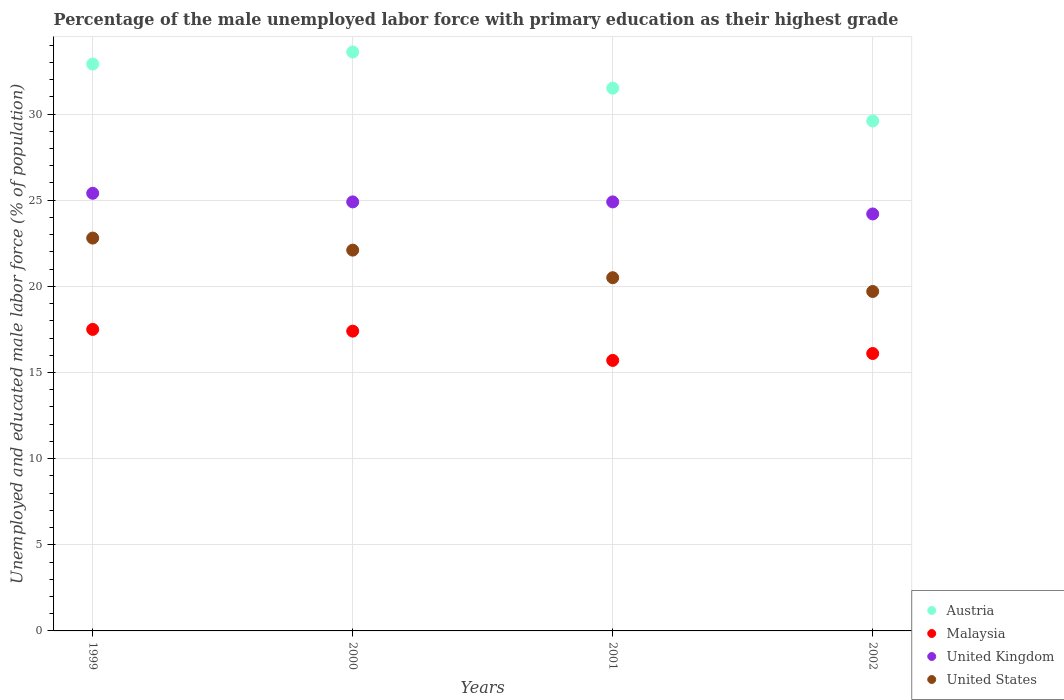How many different coloured dotlines are there?
Keep it short and to the point. 4. What is the percentage of the unemployed male labor force with primary education in United Kingdom in 2001?
Keep it short and to the point. 24.9. Across all years, what is the maximum percentage of the unemployed male labor force with primary education in Austria?
Your answer should be very brief. 33.6. Across all years, what is the minimum percentage of the unemployed male labor force with primary education in United Kingdom?
Keep it short and to the point. 24.2. What is the total percentage of the unemployed male labor force with primary education in Austria in the graph?
Your response must be concise. 127.6. What is the difference between the percentage of the unemployed male labor force with primary education in United States in 2000 and that in 2001?
Your answer should be very brief. 1.6. What is the difference between the percentage of the unemployed male labor force with primary education in United Kingdom in 2001 and the percentage of the unemployed male labor force with primary education in Austria in 2000?
Offer a terse response. -8.7. What is the average percentage of the unemployed male labor force with primary education in United Kingdom per year?
Provide a succinct answer. 24.85. In the year 1999, what is the difference between the percentage of the unemployed male labor force with primary education in United States and percentage of the unemployed male labor force with primary education in United Kingdom?
Keep it short and to the point. -2.6. In how many years, is the percentage of the unemployed male labor force with primary education in Austria greater than 4 %?
Offer a very short reply. 4. What is the ratio of the percentage of the unemployed male labor force with primary education in United States in 2001 to that in 2002?
Offer a very short reply. 1.04. Is the percentage of the unemployed male labor force with primary education in United States in 1999 less than that in 2001?
Keep it short and to the point. No. Is the difference between the percentage of the unemployed male labor force with primary education in United States in 1999 and 2001 greater than the difference between the percentage of the unemployed male labor force with primary education in United Kingdom in 1999 and 2001?
Provide a succinct answer. Yes. What is the difference between the highest and the second highest percentage of the unemployed male labor force with primary education in Malaysia?
Your answer should be compact. 0.1. What is the difference between the highest and the lowest percentage of the unemployed male labor force with primary education in Austria?
Your answer should be very brief. 4. In how many years, is the percentage of the unemployed male labor force with primary education in Malaysia greater than the average percentage of the unemployed male labor force with primary education in Malaysia taken over all years?
Your answer should be very brief. 2. Is the sum of the percentage of the unemployed male labor force with primary education in Austria in 2000 and 2002 greater than the maximum percentage of the unemployed male labor force with primary education in United States across all years?
Your answer should be compact. Yes. Is it the case that in every year, the sum of the percentage of the unemployed male labor force with primary education in United Kingdom and percentage of the unemployed male labor force with primary education in Austria  is greater than the sum of percentage of the unemployed male labor force with primary education in Malaysia and percentage of the unemployed male labor force with primary education in United States?
Keep it short and to the point. Yes. Does the percentage of the unemployed male labor force with primary education in Austria monotonically increase over the years?
Keep it short and to the point. No. Is the percentage of the unemployed male labor force with primary education in United Kingdom strictly less than the percentage of the unemployed male labor force with primary education in United States over the years?
Provide a short and direct response. No. How many dotlines are there?
Your response must be concise. 4. How many years are there in the graph?
Your answer should be very brief. 4. Does the graph contain grids?
Give a very brief answer. Yes. Where does the legend appear in the graph?
Keep it short and to the point. Bottom right. What is the title of the graph?
Give a very brief answer. Percentage of the male unemployed labor force with primary education as their highest grade. What is the label or title of the X-axis?
Offer a terse response. Years. What is the label or title of the Y-axis?
Give a very brief answer. Unemployed and educated male labor force (% of population). What is the Unemployed and educated male labor force (% of population) in Austria in 1999?
Your answer should be compact. 32.9. What is the Unemployed and educated male labor force (% of population) of United Kingdom in 1999?
Make the answer very short. 25.4. What is the Unemployed and educated male labor force (% of population) in United States in 1999?
Make the answer very short. 22.8. What is the Unemployed and educated male labor force (% of population) of Austria in 2000?
Give a very brief answer. 33.6. What is the Unemployed and educated male labor force (% of population) in Malaysia in 2000?
Provide a short and direct response. 17.4. What is the Unemployed and educated male labor force (% of population) of United Kingdom in 2000?
Your response must be concise. 24.9. What is the Unemployed and educated male labor force (% of population) of United States in 2000?
Make the answer very short. 22.1. What is the Unemployed and educated male labor force (% of population) in Austria in 2001?
Make the answer very short. 31.5. What is the Unemployed and educated male labor force (% of population) in Malaysia in 2001?
Provide a short and direct response. 15.7. What is the Unemployed and educated male labor force (% of population) in United Kingdom in 2001?
Ensure brevity in your answer.  24.9. What is the Unemployed and educated male labor force (% of population) of Austria in 2002?
Your answer should be compact. 29.6. What is the Unemployed and educated male labor force (% of population) in Malaysia in 2002?
Make the answer very short. 16.1. What is the Unemployed and educated male labor force (% of population) of United Kingdom in 2002?
Provide a succinct answer. 24.2. What is the Unemployed and educated male labor force (% of population) of United States in 2002?
Make the answer very short. 19.7. Across all years, what is the maximum Unemployed and educated male labor force (% of population) of Austria?
Ensure brevity in your answer.  33.6. Across all years, what is the maximum Unemployed and educated male labor force (% of population) of United Kingdom?
Provide a succinct answer. 25.4. Across all years, what is the maximum Unemployed and educated male labor force (% of population) of United States?
Provide a short and direct response. 22.8. Across all years, what is the minimum Unemployed and educated male labor force (% of population) of Austria?
Make the answer very short. 29.6. Across all years, what is the minimum Unemployed and educated male labor force (% of population) in Malaysia?
Offer a very short reply. 15.7. Across all years, what is the minimum Unemployed and educated male labor force (% of population) in United Kingdom?
Offer a terse response. 24.2. Across all years, what is the minimum Unemployed and educated male labor force (% of population) of United States?
Provide a succinct answer. 19.7. What is the total Unemployed and educated male labor force (% of population) of Austria in the graph?
Ensure brevity in your answer.  127.6. What is the total Unemployed and educated male labor force (% of population) of Malaysia in the graph?
Provide a succinct answer. 66.7. What is the total Unemployed and educated male labor force (% of population) in United Kingdom in the graph?
Provide a succinct answer. 99.4. What is the total Unemployed and educated male labor force (% of population) of United States in the graph?
Ensure brevity in your answer.  85.1. What is the difference between the Unemployed and educated male labor force (% of population) of Austria in 1999 and that in 2000?
Your answer should be very brief. -0.7. What is the difference between the Unemployed and educated male labor force (% of population) of Malaysia in 1999 and that in 2000?
Offer a very short reply. 0.1. What is the difference between the Unemployed and educated male labor force (% of population) of United Kingdom in 1999 and that in 2000?
Offer a terse response. 0.5. What is the difference between the Unemployed and educated male labor force (% of population) in United States in 1999 and that in 2000?
Keep it short and to the point. 0.7. What is the difference between the Unemployed and educated male labor force (% of population) of Malaysia in 1999 and that in 2001?
Offer a terse response. 1.8. What is the difference between the Unemployed and educated male labor force (% of population) of United Kingdom in 1999 and that in 2001?
Your answer should be compact. 0.5. What is the difference between the Unemployed and educated male labor force (% of population) in United States in 1999 and that in 2001?
Your answer should be very brief. 2.3. What is the difference between the Unemployed and educated male labor force (% of population) in United Kingdom in 1999 and that in 2002?
Give a very brief answer. 1.2. What is the difference between the Unemployed and educated male labor force (% of population) of United States in 1999 and that in 2002?
Your answer should be compact. 3.1. What is the difference between the Unemployed and educated male labor force (% of population) of Malaysia in 2000 and that in 2001?
Your answer should be compact. 1.7. What is the difference between the Unemployed and educated male labor force (% of population) of United States in 2000 and that in 2001?
Give a very brief answer. 1.6. What is the difference between the Unemployed and educated male labor force (% of population) of Austria in 2000 and that in 2002?
Provide a short and direct response. 4. What is the difference between the Unemployed and educated male labor force (% of population) of Austria in 2001 and that in 2002?
Your answer should be compact. 1.9. What is the difference between the Unemployed and educated male labor force (% of population) of Austria in 1999 and the Unemployed and educated male labor force (% of population) of Malaysia in 2000?
Offer a terse response. 15.5. What is the difference between the Unemployed and educated male labor force (% of population) in Malaysia in 1999 and the Unemployed and educated male labor force (% of population) in United States in 2000?
Provide a succinct answer. -4.6. What is the difference between the Unemployed and educated male labor force (% of population) of Austria in 1999 and the Unemployed and educated male labor force (% of population) of Malaysia in 2001?
Your answer should be compact. 17.2. What is the difference between the Unemployed and educated male labor force (% of population) in Austria in 1999 and the Unemployed and educated male labor force (% of population) in United Kingdom in 2002?
Ensure brevity in your answer.  8.7. What is the difference between the Unemployed and educated male labor force (% of population) in Malaysia in 1999 and the Unemployed and educated male labor force (% of population) in United States in 2002?
Make the answer very short. -2.2. What is the difference between the Unemployed and educated male labor force (% of population) in Austria in 2000 and the Unemployed and educated male labor force (% of population) in United Kingdom in 2001?
Provide a succinct answer. 8.7. What is the difference between the Unemployed and educated male labor force (% of population) of Austria in 2000 and the Unemployed and educated male labor force (% of population) of United States in 2001?
Your response must be concise. 13.1. What is the difference between the Unemployed and educated male labor force (% of population) in Malaysia in 2000 and the Unemployed and educated male labor force (% of population) in United States in 2001?
Keep it short and to the point. -3.1. What is the difference between the Unemployed and educated male labor force (% of population) in Austria in 2000 and the Unemployed and educated male labor force (% of population) in Malaysia in 2002?
Keep it short and to the point. 17.5. What is the difference between the Unemployed and educated male labor force (% of population) in Austria in 2000 and the Unemployed and educated male labor force (% of population) in United Kingdom in 2002?
Keep it short and to the point. 9.4. What is the difference between the Unemployed and educated male labor force (% of population) of Austria in 2000 and the Unemployed and educated male labor force (% of population) of United States in 2002?
Provide a succinct answer. 13.9. What is the difference between the Unemployed and educated male labor force (% of population) of Malaysia in 2000 and the Unemployed and educated male labor force (% of population) of United Kingdom in 2002?
Keep it short and to the point. -6.8. What is the difference between the Unemployed and educated male labor force (% of population) of United Kingdom in 2000 and the Unemployed and educated male labor force (% of population) of United States in 2002?
Keep it short and to the point. 5.2. What is the difference between the Unemployed and educated male labor force (% of population) in Austria in 2001 and the Unemployed and educated male labor force (% of population) in Malaysia in 2002?
Offer a terse response. 15.4. What is the difference between the Unemployed and educated male labor force (% of population) of Austria in 2001 and the Unemployed and educated male labor force (% of population) of United Kingdom in 2002?
Provide a short and direct response. 7.3. What is the difference between the Unemployed and educated male labor force (% of population) of Austria in 2001 and the Unemployed and educated male labor force (% of population) of United States in 2002?
Give a very brief answer. 11.8. What is the difference between the Unemployed and educated male labor force (% of population) in Malaysia in 2001 and the Unemployed and educated male labor force (% of population) in United Kingdom in 2002?
Your response must be concise. -8.5. What is the difference between the Unemployed and educated male labor force (% of population) in United Kingdom in 2001 and the Unemployed and educated male labor force (% of population) in United States in 2002?
Provide a short and direct response. 5.2. What is the average Unemployed and educated male labor force (% of population) of Austria per year?
Ensure brevity in your answer.  31.9. What is the average Unemployed and educated male labor force (% of population) in Malaysia per year?
Provide a short and direct response. 16.68. What is the average Unemployed and educated male labor force (% of population) of United Kingdom per year?
Ensure brevity in your answer.  24.85. What is the average Unemployed and educated male labor force (% of population) in United States per year?
Offer a very short reply. 21.27. In the year 1999, what is the difference between the Unemployed and educated male labor force (% of population) of Austria and Unemployed and educated male labor force (% of population) of Malaysia?
Give a very brief answer. 15.4. In the year 1999, what is the difference between the Unemployed and educated male labor force (% of population) in Austria and Unemployed and educated male labor force (% of population) in United States?
Your answer should be compact. 10.1. In the year 1999, what is the difference between the Unemployed and educated male labor force (% of population) of Malaysia and Unemployed and educated male labor force (% of population) of United States?
Provide a succinct answer. -5.3. In the year 2000, what is the difference between the Unemployed and educated male labor force (% of population) of Austria and Unemployed and educated male labor force (% of population) of Malaysia?
Offer a very short reply. 16.2. In the year 2000, what is the difference between the Unemployed and educated male labor force (% of population) in Malaysia and Unemployed and educated male labor force (% of population) in United States?
Provide a short and direct response. -4.7. In the year 2001, what is the difference between the Unemployed and educated male labor force (% of population) in Austria and Unemployed and educated male labor force (% of population) in Malaysia?
Provide a succinct answer. 15.8. In the year 2001, what is the difference between the Unemployed and educated male labor force (% of population) of Malaysia and Unemployed and educated male labor force (% of population) of United Kingdom?
Keep it short and to the point. -9.2. In the year 2001, what is the difference between the Unemployed and educated male labor force (% of population) in United Kingdom and Unemployed and educated male labor force (% of population) in United States?
Ensure brevity in your answer.  4.4. In the year 2002, what is the difference between the Unemployed and educated male labor force (% of population) in Austria and Unemployed and educated male labor force (% of population) in United Kingdom?
Give a very brief answer. 5.4. In the year 2002, what is the difference between the Unemployed and educated male labor force (% of population) in Austria and Unemployed and educated male labor force (% of population) in United States?
Provide a succinct answer. 9.9. In the year 2002, what is the difference between the Unemployed and educated male labor force (% of population) in Malaysia and Unemployed and educated male labor force (% of population) in United Kingdom?
Your response must be concise. -8.1. In the year 2002, what is the difference between the Unemployed and educated male labor force (% of population) in United Kingdom and Unemployed and educated male labor force (% of population) in United States?
Your response must be concise. 4.5. What is the ratio of the Unemployed and educated male labor force (% of population) in Austria in 1999 to that in 2000?
Your answer should be compact. 0.98. What is the ratio of the Unemployed and educated male labor force (% of population) of Malaysia in 1999 to that in 2000?
Your answer should be compact. 1.01. What is the ratio of the Unemployed and educated male labor force (% of population) of United Kingdom in 1999 to that in 2000?
Offer a terse response. 1.02. What is the ratio of the Unemployed and educated male labor force (% of population) of United States in 1999 to that in 2000?
Make the answer very short. 1.03. What is the ratio of the Unemployed and educated male labor force (% of population) in Austria in 1999 to that in 2001?
Offer a terse response. 1.04. What is the ratio of the Unemployed and educated male labor force (% of population) of Malaysia in 1999 to that in 2001?
Ensure brevity in your answer.  1.11. What is the ratio of the Unemployed and educated male labor force (% of population) in United Kingdom in 1999 to that in 2001?
Offer a terse response. 1.02. What is the ratio of the Unemployed and educated male labor force (% of population) of United States in 1999 to that in 2001?
Make the answer very short. 1.11. What is the ratio of the Unemployed and educated male labor force (% of population) in Austria in 1999 to that in 2002?
Give a very brief answer. 1.11. What is the ratio of the Unemployed and educated male labor force (% of population) of Malaysia in 1999 to that in 2002?
Provide a short and direct response. 1.09. What is the ratio of the Unemployed and educated male labor force (% of population) of United Kingdom in 1999 to that in 2002?
Your answer should be very brief. 1.05. What is the ratio of the Unemployed and educated male labor force (% of population) in United States in 1999 to that in 2002?
Give a very brief answer. 1.16. What is the ratio of the Unemployed and educated male labor force (% of population) in Austria in 2000 to that in 2001?
Your answer should be compact. 1.07. What is the ratio of the Unemployed and educated male labor force (% of population) of Malaysia in 2000 to that in 2001?
Offer a terse response. 1.11. What is the ratio of the Unemployed and educated male labor force (% of population) of United Kingdom in 2000 to that in 2001?
Your answer should be very brief. 1. What is the ratio of the Unemployed and educated male labor force (% of population) of United States in 2000 to that in 2001?
Provide a short and direct response. 1.08. What is the ratio of the Unemployed and educated male labor force (% of population) in Austria in 2000 to that in 2002?
Keep it short and to the point. 1.14. What is the ratio of the Unemployed and educated male labor force (% of population) of Malaysia in 2000 to that in 2002?
Keep it short and to the point. 1.08. What is the ratio of the Unemployed and educated male labor force (% of population) of United Kingdom in 2000 to that in 2002?
Ensure brevity in your answer.  1.03. What is the ratio of the Unemployed and educated male labor force (% of population) in United States in 2000 to that in 2002?
Your response must be concise. 1.12. What is the ratio of the Unemployed and educated male labor force (% of population) in Austria in 2001 to that in 2002?
Your response must be concise. 1.06. What is the ratio of the Unemployed and educated male labor force (% of population) of Malaysia in 2001 to that in 2002?
Provide a succinct answer. 0.98. What is the ratio of the Unemployed and educated male labor force (% of population) in United Kingdom in 2001 to that in 2002?
Offer a very short reply. 1.03. What is the ratio of the Unemployed and educated male labor force (% of population) in United States in 2001 to that in 2002?
Keep it short and to the point. 1.04. What is the difference between the highest and the second highest Unemployed and educated male labor force (% of population) of United Kingdom?
Offer a terse response. 0.5. What is the difference between the highest and the lowest Unemployed and educated male labor force (% of population) of Austria?
Provide a short and direct response. 4. What is the difference between the highest and the lowest Unemployed and educated male labor force (% of population) of Malaysia?
Offer a very short reply. 1.8. What is the difference between the highest and the lowest Unemployed and educated male labor force (% of population) of United Kingdom?
Provide a short and direct response. 1.2. What is the difference between the highest and the lowest Unemployed and educated male labor force (% of population) in United States?
Ensure brevity in your answer.  3.1. 